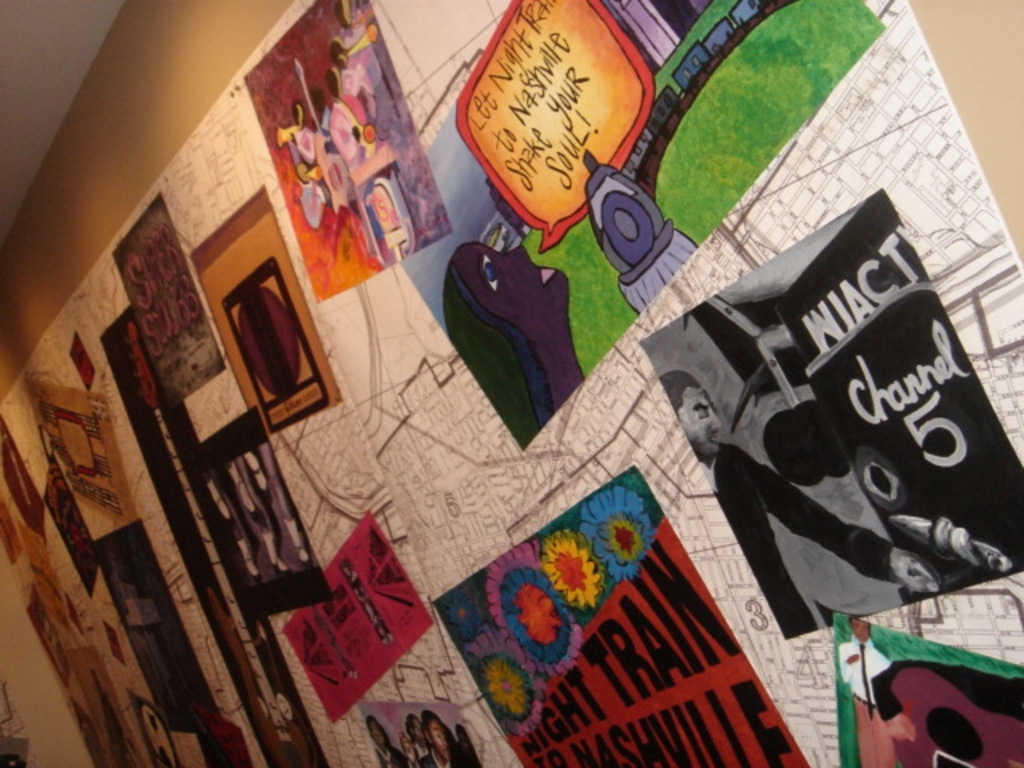Describe the style and mood conveyed by these artworks. The artworks display a vibrant, eclectic style filled with bold colors and expressive forms that evoke a sense of playful dynamism and urban cultural diversity, reflecting a festive mood that invites onlookers into the artistic world of Nashville. 